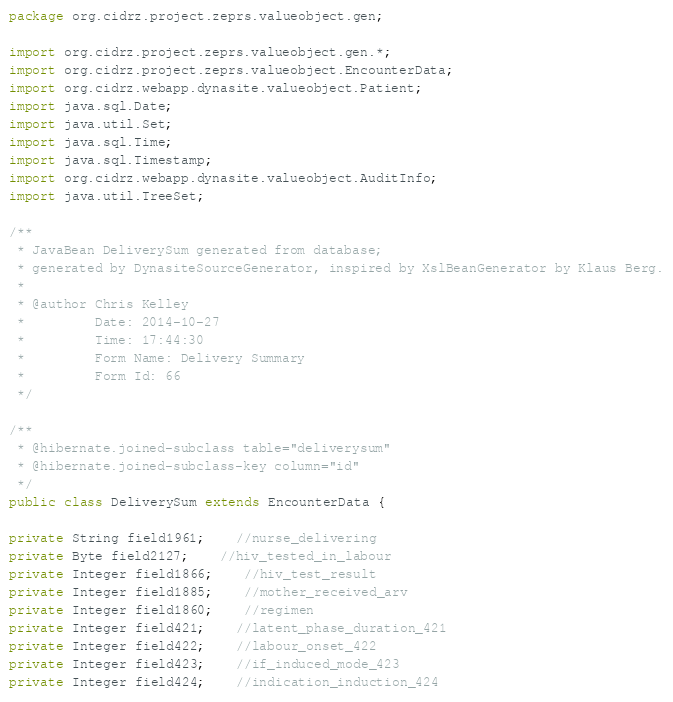Convert code to text. <code><loc_0><loc_0><loc_500><loc_500><_Java_>package org.cidrz.project.zeprs.valueobject.gen;

import org.cidrz.project.zeprs.valueobject.gen.*;
import org.cidrz.project.zeprs.valueobject.EncounterData;
import org.cidrz.webapp.dynasite.valueobject.Patient;
import java.sql.Date;
import java.util.Set;
import java.sql.Time;
import java.sql.Timestamp;
import org.cidrz.webapp.dynasite.valueobject.AuditInfo;
import java.util.TreeSet;

/**
 * JavaBean DeliverySum generated from database;
 * generated by DynasiteSourceGenerator, inspired by XslBeanGenerator by Klaus Berg.
 *
 * @author Chris Kelley
 *         Date: 2014-10-27
 *         Time: 17:44:30
 *         Form Name: Delivery Summary
 *         Form Id: 66
 */

/**
 * @hibernate.joined-subclass table="deliverysum"
 * @hibernate.joined-subclass-key column="id"
 */
public class DeliverySum extends EncounterData {

private String field1961;	//nurse_delivering
private Byte field2127;	//hiv_tested_in_labour
private Integer field1866;	//hiv_test_result
private Integer field1885;	//mother_received_arv
private Integer field1860;	//regimen
private Integer field421;	//latent_phase_duration_421
private Integer field422;	//labour_onset_422
private Integer field423;	//if_induced_mode_423
private Integer field424;	//indication_induction_424</code> 